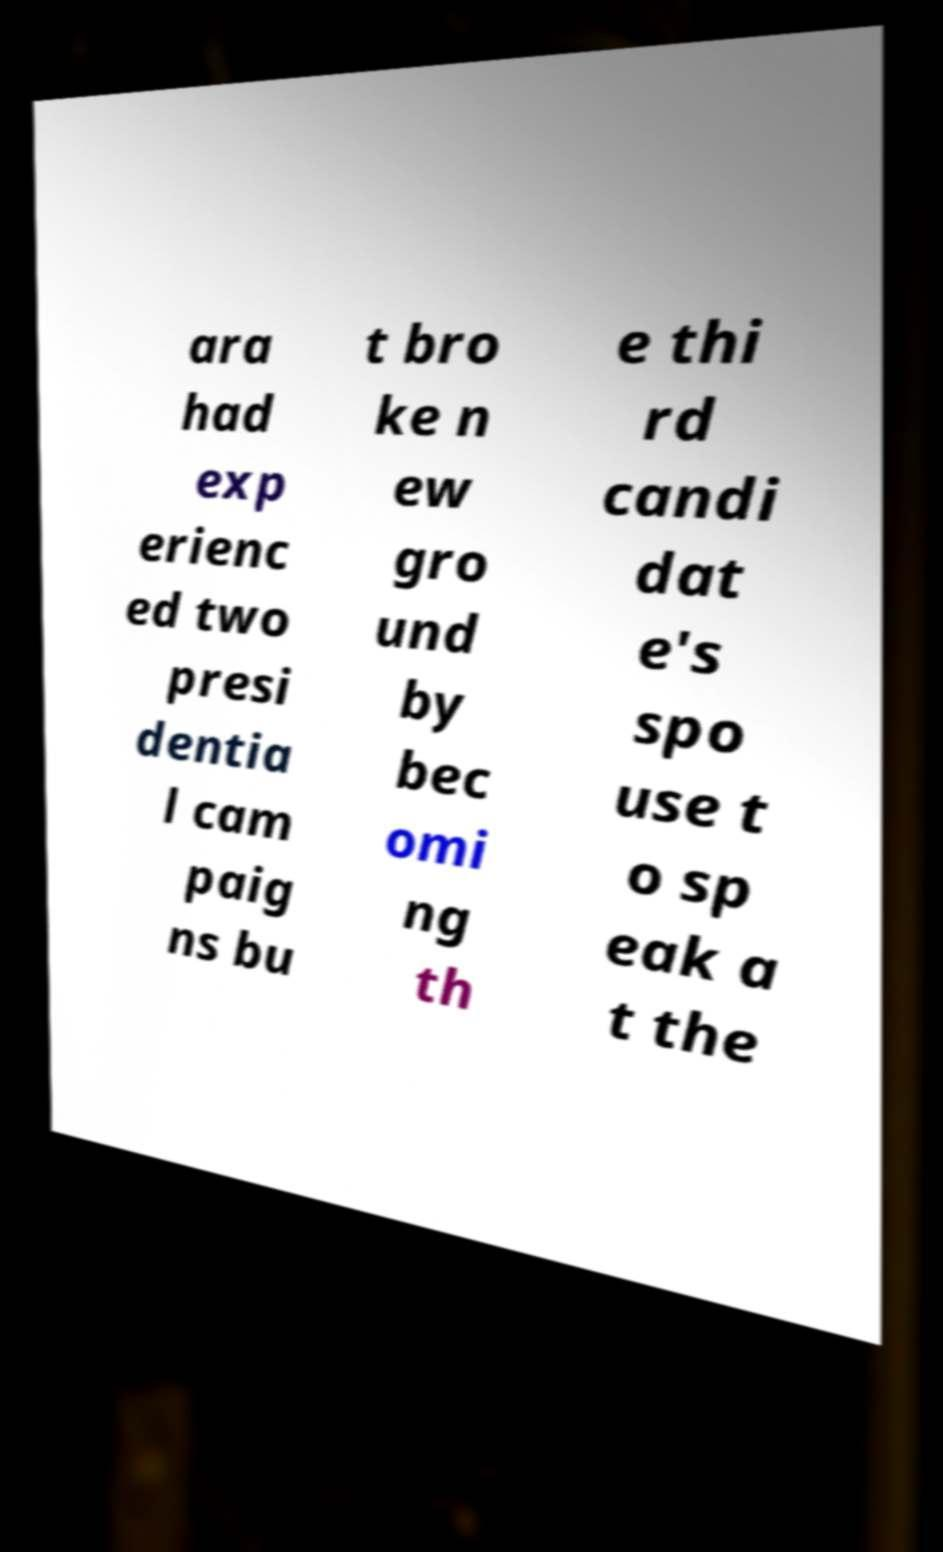Can you read and provide the text displayed in the image?This photo seems to have some interesting text. Can you extract and type it out for me? ara had exp erienc ed two presi dentia l cam paig ns bu t bro ke n ew gro und by bec omi ng th e thi rd candi dat e's spo use t o sp eak a t the 